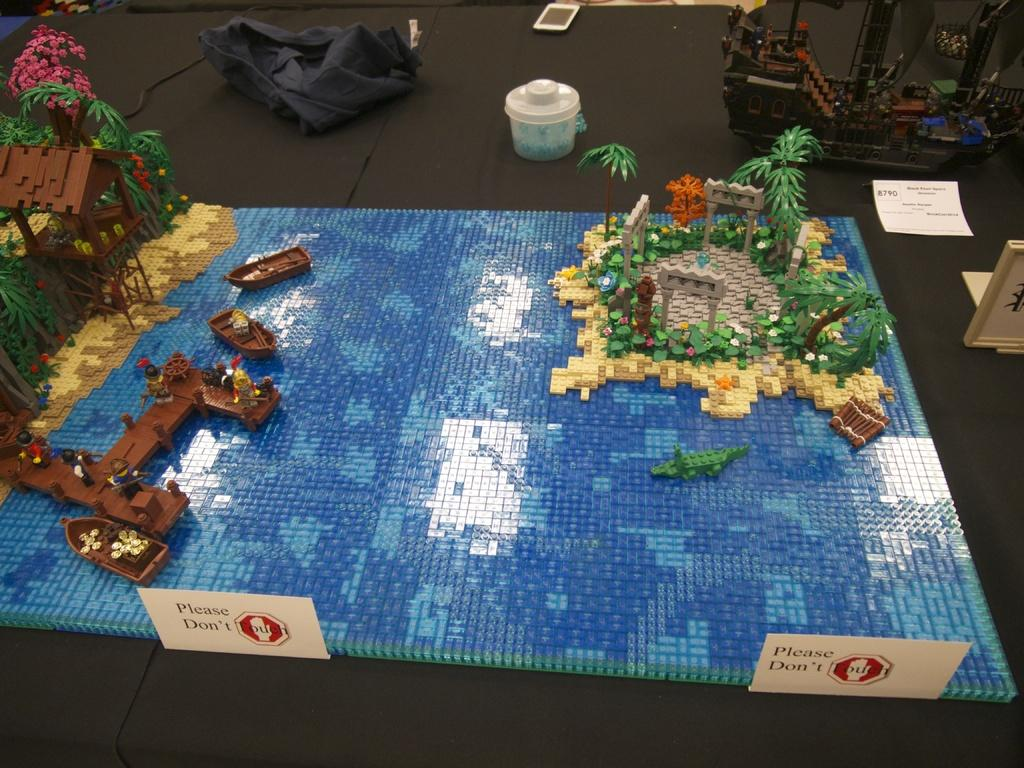What is the main subject of the image? The main subject of the image is an art piece made using building blocks. Are there any safety precautions indicated in the image? Yes, there are caution boards in the image. What electronic device is visible in the image? A mobile phone is visible in the image. What is the color of the surface on which additional objects are placed? The additional objects are placed on a black color surface in the image. Can you hear the horn of a vehicle in the image? There is no indication of a vehicle or a horn in the image. Is the park visible in the image? There is no park present in the image. 